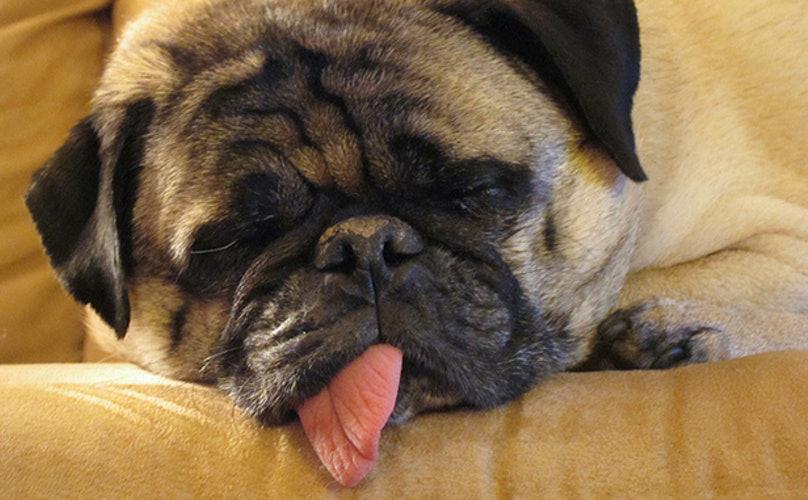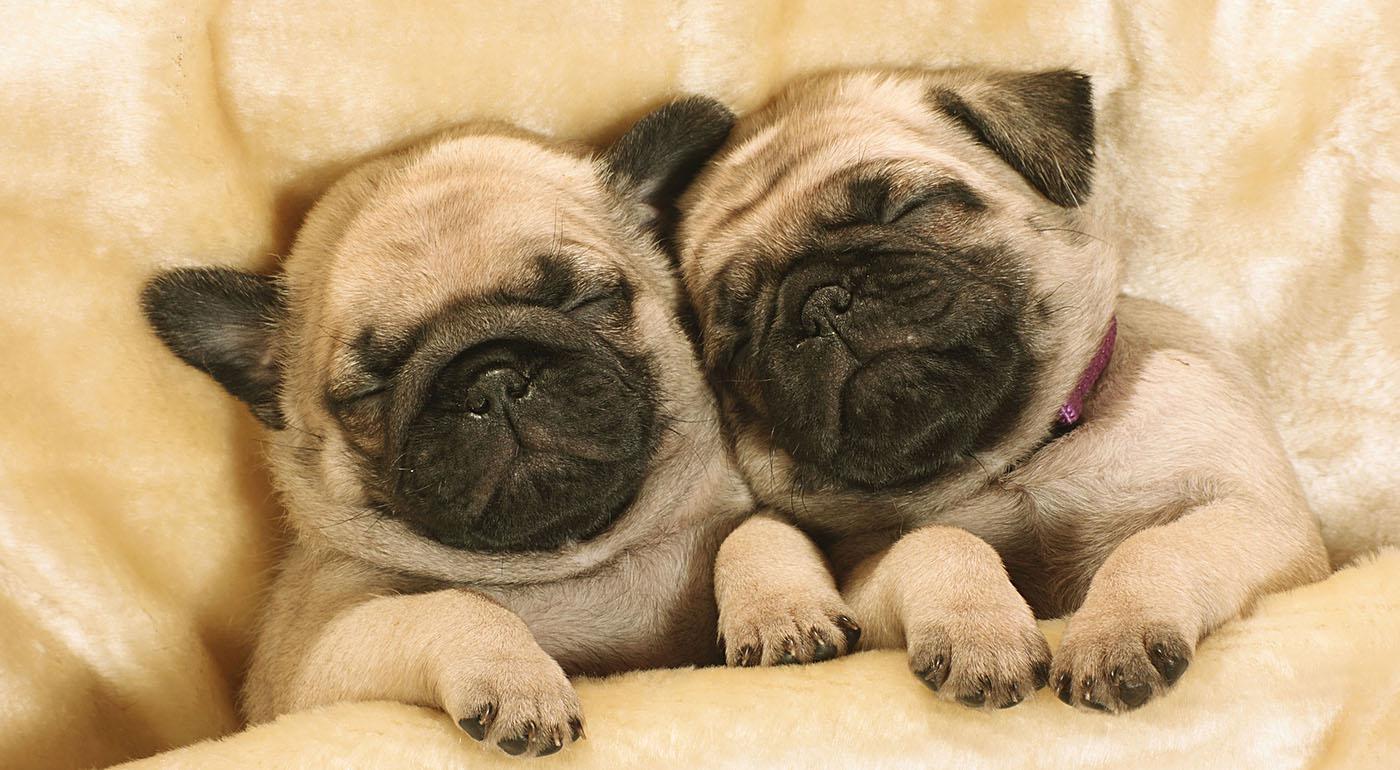The first image is the image on the left, the second image is the image on the right. Given the left and right images, does the statement "a single pug is sleeping with it's tongue sticking out" hold true? Answer yes or no. Yes. The first image is the image on the left, the second image is the image on the right. For the images shown, is this caption "One image shows pugs sleeping side-by-side on something plush, and the other image shows one sleeping pug with its tongue hanging out." true? Answer yes or no. Yes. 